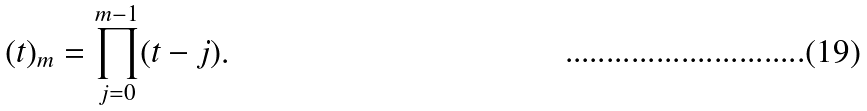Convert formula to latex. <formula><loc_0><loc_0><loc_500><loc_500>( t ) _ { m } = \prod _ { j = 0 } ^ { m - 1 } ( t - j ) .</formula> 